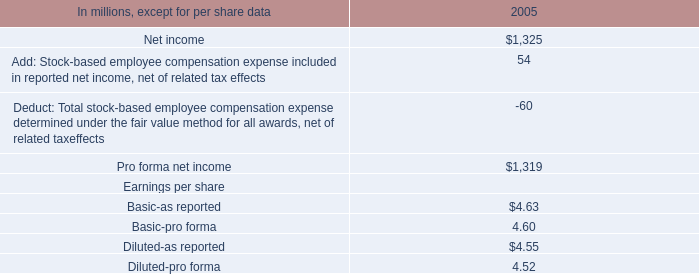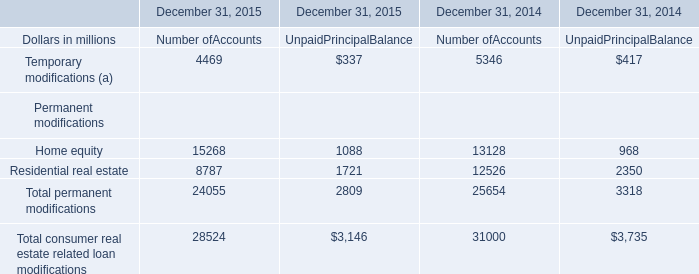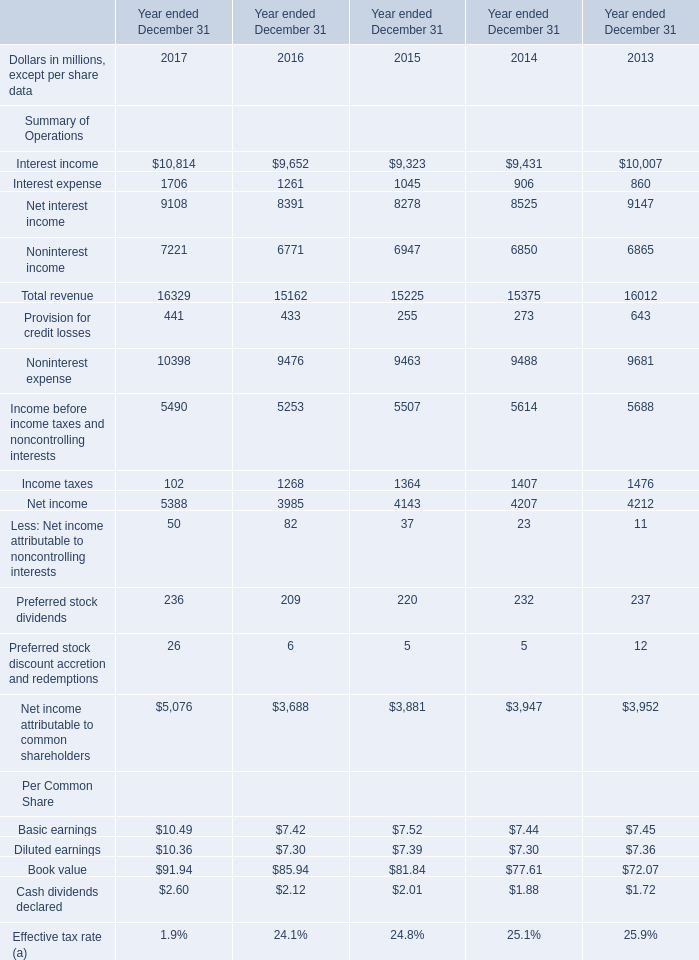What is the average amount of Home equity Permanent modifications of December 31, 2015 Number ofAccounts, and Noninterest expense of Year ended December 31 2014 ? 
Computations: ((15268.0 + 9488.0) / 2)
Answer: 12378.0. 